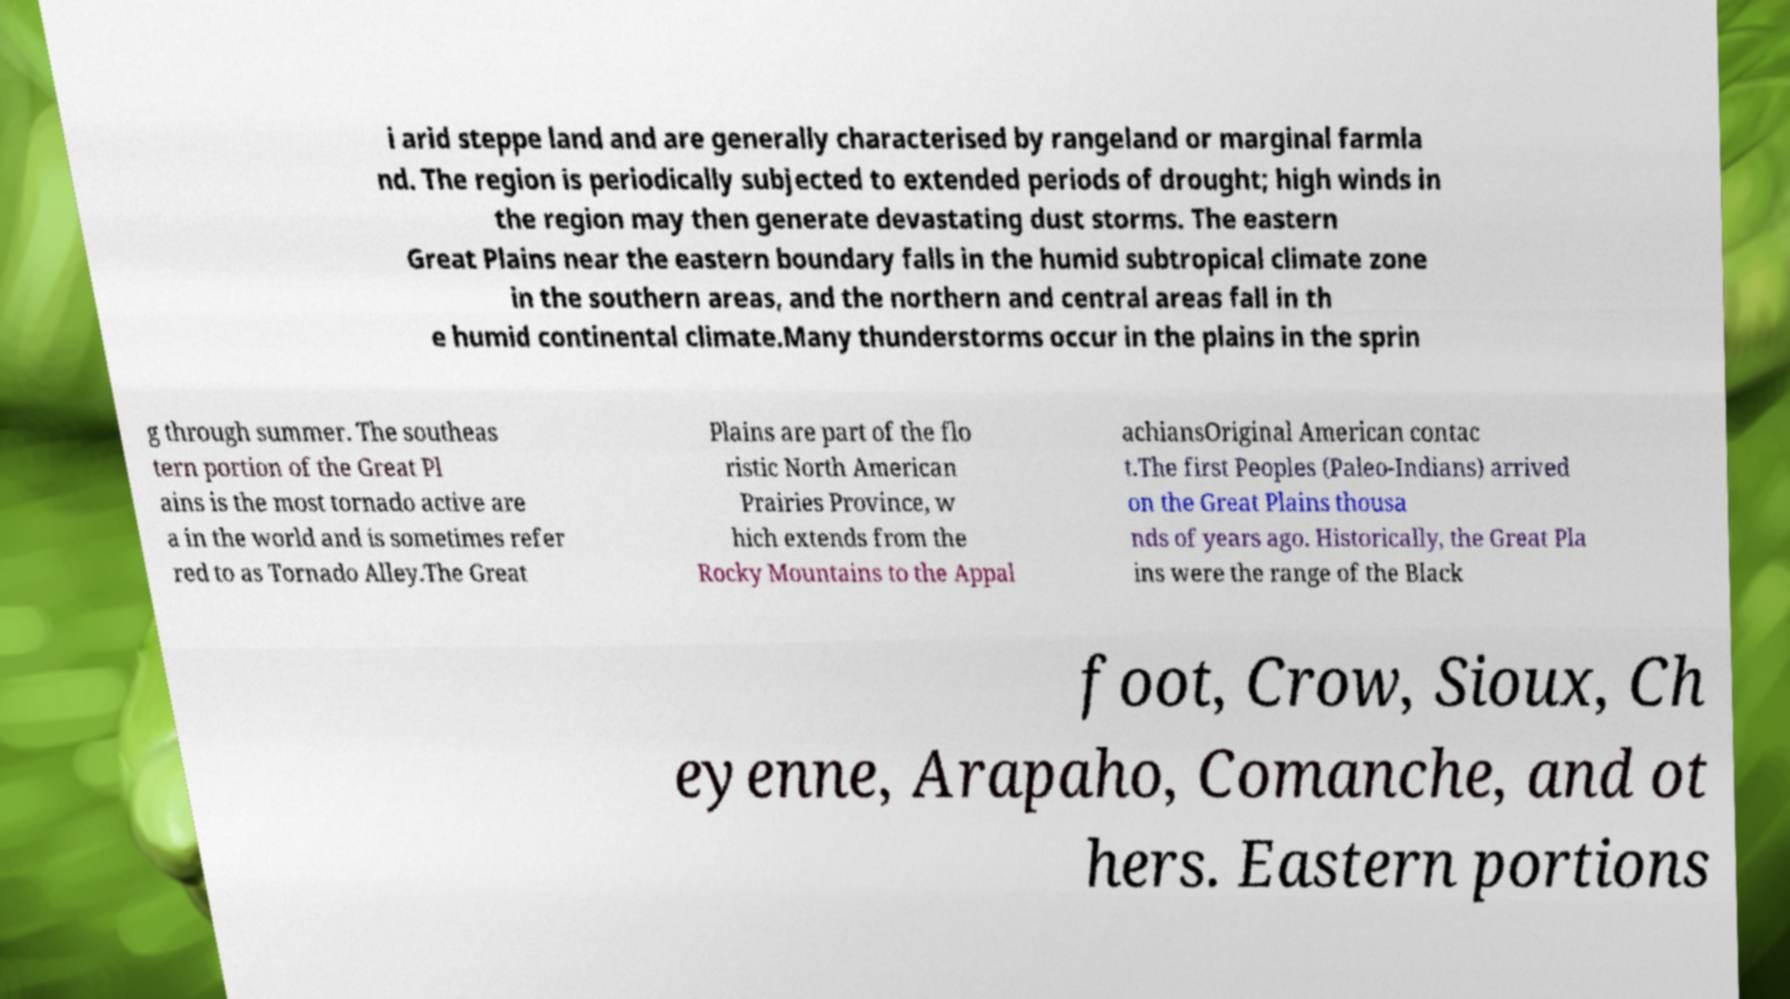Please identify and transcribe the text found in this image. i arid steppe land and are generally characterised by rangeland or marginal farmla nd. The region is periodically subjected to extended periods of drought; high winds in the region may then generate devastating dust storms. The eastern Great Plains near the eastern boundary falls in the humid subtropical climate zone in the southern areas, and the northern and central areas fall in th e humid continental climate.Many thunderstorms occur in the plains in the sprin g through summer. The southeas tern portion of the Great Pl ains is the most tornado active are a in the world and is sometimes refer red to as Tornado Alley.The Great Plains are part of the flo ristic North American Prairies Province, w hich extends from the Rocky Mountains to the Appal achiansOriginal American contac t.The first Peoples (Paleo-Indians) arrived on the Great Plains thousa nds of years ago. Historically, the Great Pla ins were the range of the Black foot, Crow, Sioux, Ch eyenne, Arapaho, Comanche, and ot hers. Eastern portions 